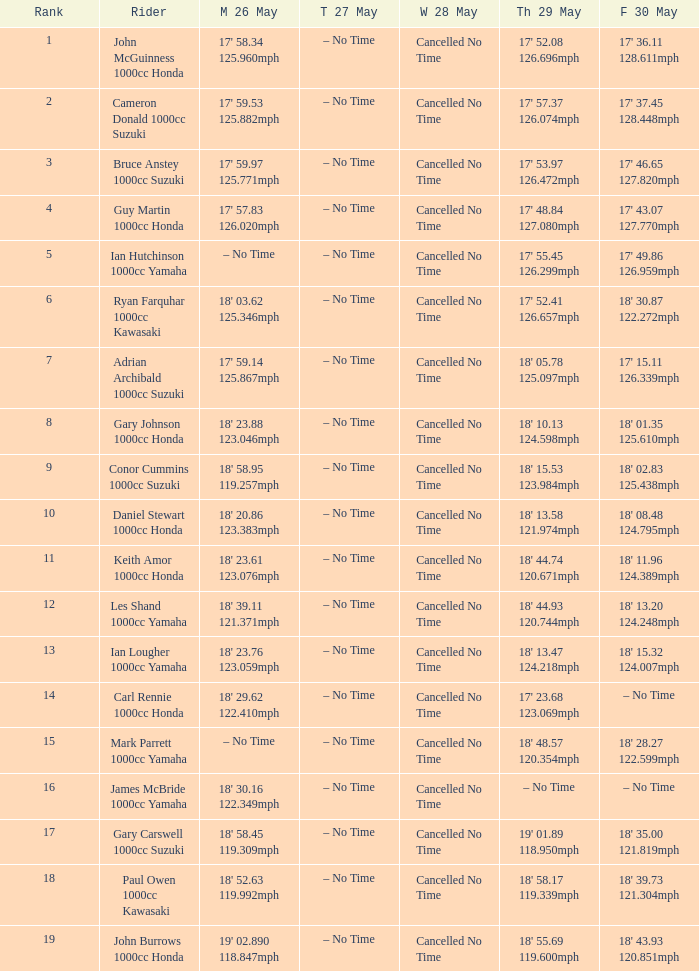What is the numbr for fri may 30 and mon may 26 is 19' 02.890 118.847mph? 18' 43.93 120.851mph. 